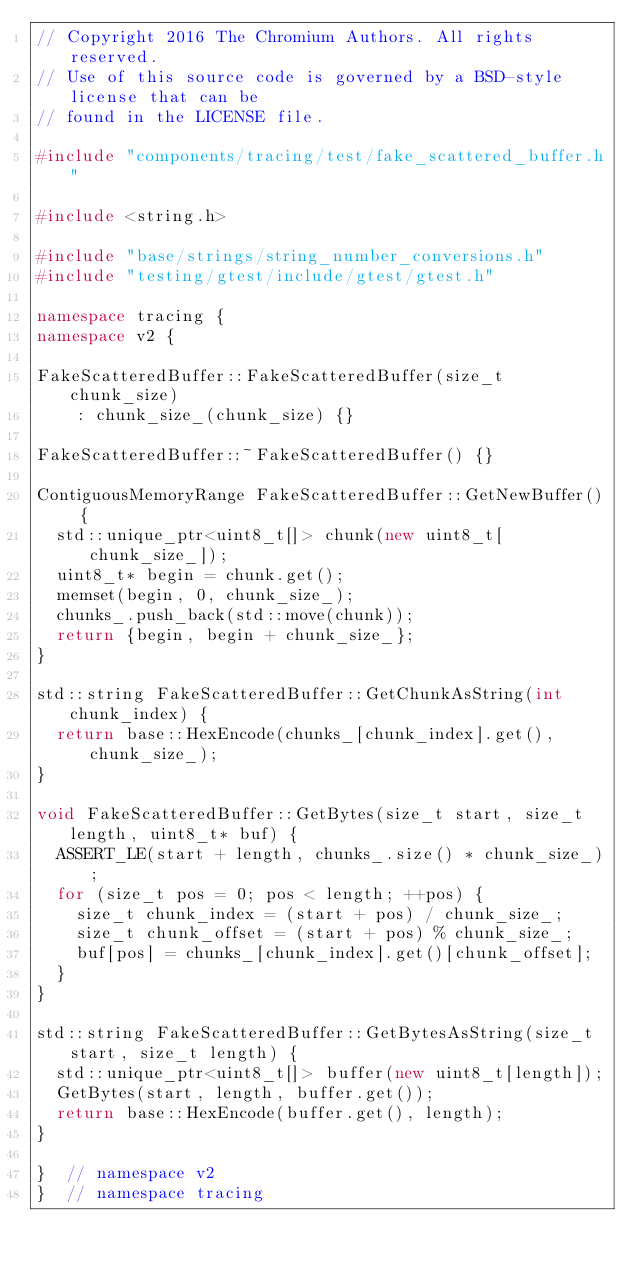<code> <loc_0><loc_0><loc_500><loc_500><_C++_>// Copyright 2016 The Chromium Authors. All rights reserved.
// Use of this source code is governed by a BSD-style license that can be
// found in the LICENSE file.

#include "components/tracing/test/fake_scattered_buffer.h"

#include <string.h>

#include "base/strings/string_number_conversions.h"
#include "testing/gtest/include/gtest/gtest.h"

namespace tracing {
namespace v2 {

FakeScatteredBuffer::FakeScatteredBuffer(size_t chunk_size)
    : chunk_size_(chunk_size) {}

FakeScatteredBuffer::~FakeScatteredBuffer() {}

ContiguousMemoryRange FakeScatteredBuffer::GetNewBuffer() {
  std::unique_ptr<uint8_t[]> chunk(new uint8_t[chunk_size_]);
  uint8_t* begin = chunk.get();
  memset(begin, 0, chunk_size_);
  chunks_.push_back(std::move(chunk));
  return {begin, begin + chunk_size_};
}

std::string FakeScatteredBuffer::GetChunkAsString(int chunk_index) {
  return base::HexEncode(chunks_[chunk_index].get(), chunk_size_);
}

void FakeScatteredBuffer::GetBytes(size_t start, size_t length, uint8_t* buf) {
  ASSERT_LE(start + length, chunks_.size() * chunk_size_);
  for (size_t pos = 0; pos < length; ++pos) {
    size_t chunk_index = (start + pos) / chunk_size_;
    size_t chunk_offset = (start + pos) % chunk_size_;
    buf[pos] = chunks_[chunk_index].get()[chunk_offset];
  }
}

std::string FakeScatteredBuffer::GetBytesAsString(size_t start, size_t length) {
  std::unique_ptr<uint8_t[]> buffer(new uint8_t[length]);
  GetBytes(start, length, buffer.get());
  return base::HexEncode(buffer.get(), length);
}

}  // namespace v2
}  // namespace tracing
</code> 